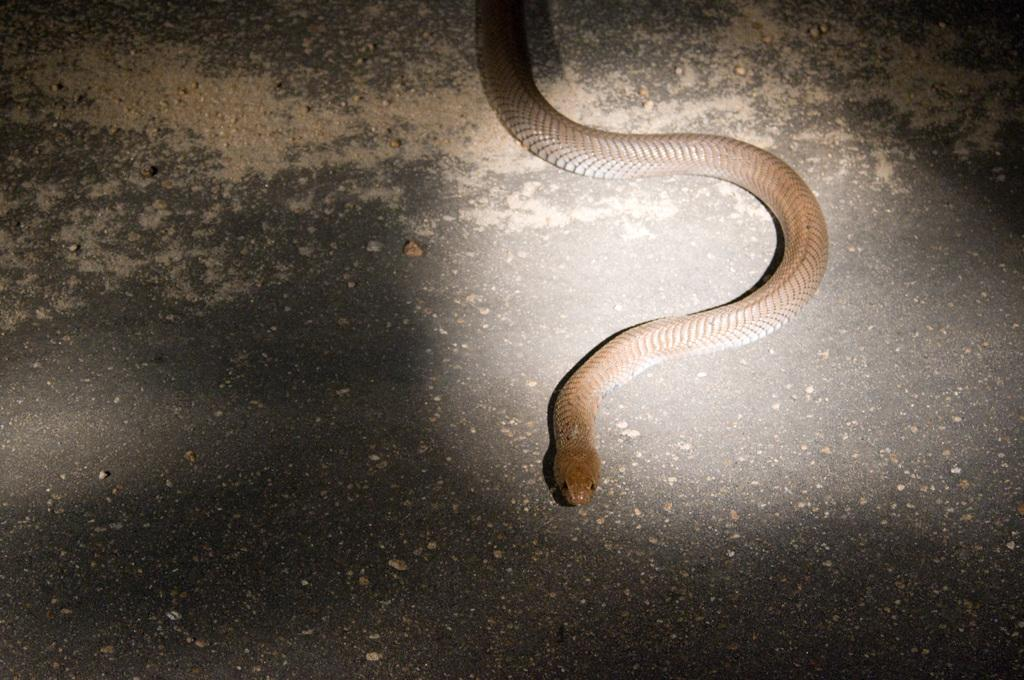What animal is present in the image? There is a snake in the image. Where is the snake located? The snake is on the road. What type of squirrel can be seen interacting with the snake in the image? There is no squirrel present in the image, and the snake is not interacting with any other animals. 